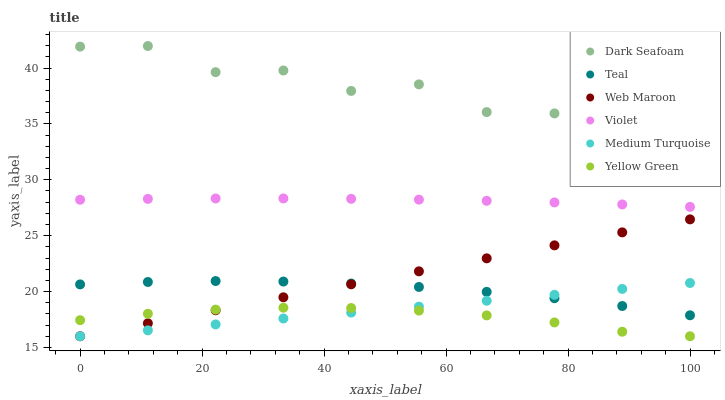Does Yellow Green have the minimum area under the curve?
Answer yes or no. Yes. Does Dark Seafoam have the maximum area under the curve?
Answer yes or no. Yes. Does Web Maroon have the minimum area under the curve?
Answer yes or no. No. Does Web Maroon have the maximum area under the curve?
Answer yes or no. No. Is Web Maroon the smoothest?
Answer yes or no. Yes. Is Dark Seafoam the roughest?
Answer yes or no. Yes. Is Yellow Green the smoothest?
Answer yes or no. No. Is Yellow Green the roughest?
Answer yes or no. No. Does Yellow Green have the lowest value?
Answer yes or no. Yes. Does Dark Seafoam have the lowest value?
Answer yes or no. No. Does Dark Seafoam have the highest value?
Answer yes or no. Yes. Does Web Maroon have the highest value?
Answer yes or no. No. Is Medium Turquoise less than Violet?
Answer yes or no. Yes. Is Dark Seafoam greater than Violet?
Answer yes or no. Yes. Does Medium Turquoise intersect Teal?
Answer yes or no. Yes. Is Medium Turquoise less than Teal?
Answer yes or no. No. Is Medium Turquoise greater than Teal?
Answer yes or no. No. Does Medium Turquoise intersect Violet?
Answer yes or no. No. 